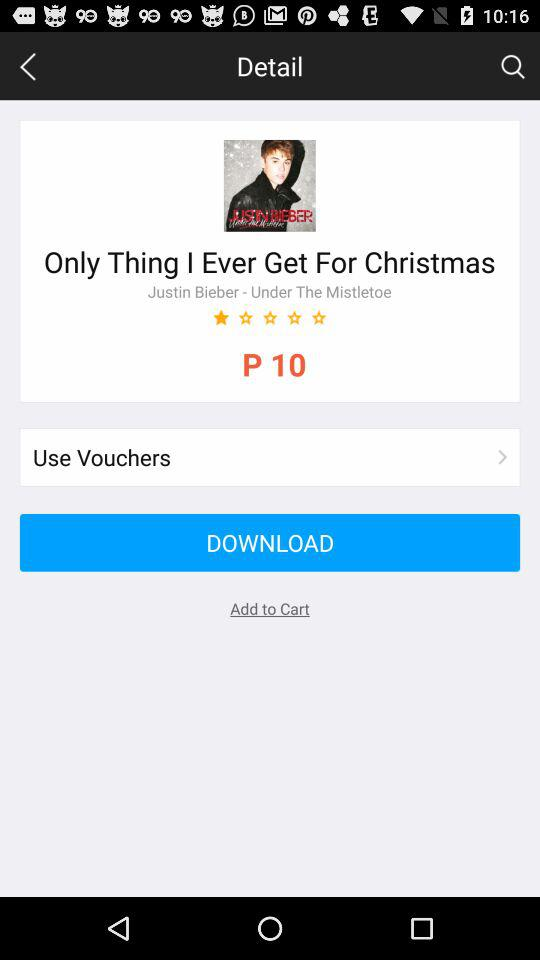What is the rating of the song? The rating is 1 star. 